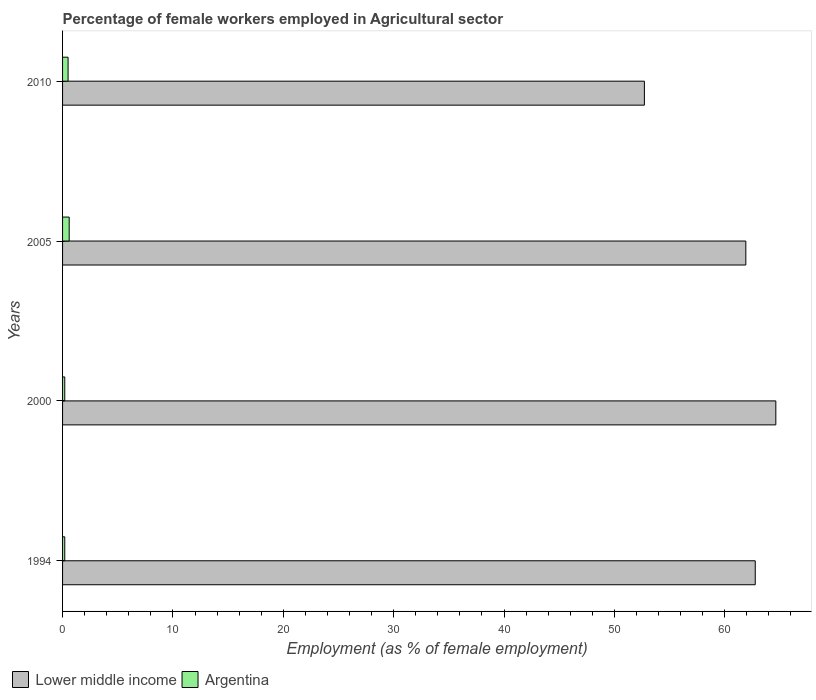How many different coloured bars are there?
Offer a terse response. 2. How many groups of bars are there?
Ensure brevity in your answer.  4. Are the number of bars on each tick of the Y-axis equal?
Make the answer very short. Yes. In how many cases, is the number of bars for a given year not equal to the number of legend labels?
Your response must be concise. 0. What is the percentage of females employed in Agricultural sector in Lower middle income in 2010?
Your answer should be very brief. 52.72. Across all years, what is the maximum percentage of females employed in Agricultural sector in Argentina?
Make the answer very short. 0.6. Across all years, what is the minimum percentage of females employed in Agricultural sector in Argentina?
Provide a succinct answer. 0.2. In which year was the percentage of females employed in Agricultural sector in Argentina maximum?
Keep it short and to the point. 2005. In which year was the percentage of females employed in Agricultural sector in Argentina minimum?
Your response must be concise. 1994. What is the total percentage of females employed in Agricultural sector in Argentina in the graph?
Offer a terse response. 1.5. What is the difference between the percentage of females employed in Agricultural sector in Lower middle income in 1994 and that in 2000?
Make the answer very short. -1.86. What is the difference between the percentage of females employed in Agricultural sector in Argentina in 2005 and the percentage of females employed in Agricultural sector in Lower middle income in 1994?
Offer a very short reply. -62.16. What is the average percentage of females employed in Agricultural sector in Lower middle income per year?
Your response must be concise. 60.5. In the year 2010, what is the difference between the percentage of females employed in Agricultural sector in Argentina and percentage of females employed in Agricultural sector in Lower middle income?
Keep it short and to the point. -52.22. In how many years, is the percentage of females employed in Agricultural sector in Argentina greater than 40 %?
Keep it short and to the point. 0. What is the ratio of the percentage of females employed in Agricultural sector in Lower middle income in 1994 to that in 2010?
Offer a very short reply. 1.19. What is the difference between the highest and the second highest percentage of females employed in Agricultural sector in Lower middle income?
Offer a terse response. 1.86. What is the difference between the highest and the lowest percentage of females employed in Agricultural sector in Lower middle income?
Make the answer very short. 11.91. In how many years, is the percentage of females employed in Agricultural sector in Lower middle income greater than the average percentage of females employed in Agricultural sector in Lower middle income taken over all years?
Your response must be concise. 3. What does the 1st bar from the top in 2005 represents?
Your response must be concise. Argentina. What does the 2nd bar from the bottom in 2010 represents?
Offer a terse response. Argentina. How many bars are there?
Make the answer very short. 8. Does the graph contain any zero values?
Make the answer very short. No. What is the title of the graph?
Offer a terse response. Percentage of female workers employed in Agricultural sector. What is the label or title of the X-axis?
Offer a very short reply. Employment (as % of female employment). What is the Employment (as % of female employment) in Lower middle income in 1994?
Offer a terse response. 62.76. What is the Employment (as % of female employment) in Argentina in 1994?
Provide a succinct answer. 0.2. What is the Employment (as % of female employment) of Lower middle income in 2000?
Keep it short and to the point. 64.63. What is the Employment (as % of female employment) in Argentina in 2000?
Provide a succinct answer. 0.2. What is the Employment (as % of female employment) of Lower middle income in 2005?
Your answer should be very brief. 61.91. What is the Employment (as % of female employment) of Argentina in 2005?
Your answer should be very brief. 0.6. What is the Employment (as % of female employment) in Lower middle income in 2010?
Provide a short and direct response. 52.72. What is the Employment (as % of female employment) of Argentina in 2010?
Ensure brevity in your answer.  0.5. Across all years, what is the maximum Employment (as % of female employment) in Lower middle income?
Offer a very short reply. 64.63. Across all years, what is the maximum Employment (as % of female employment) of Argentina?
Keep it short and to the point. 0.6. Across all years, what is the minimum Employment (as % of female employment) of Lower middle income?
Provide a succinct answer. 52.72. Across all years, what is the minimum Employment (as % of female employment) in Argentina?
Make the answer very short. 0.2. What is the total Employment (as % of female employment) of Lower middle income in the graph?
Provide a short and direct response. 242.02. What is the difference between the Employment (as % of female employment) of Lower middle income in 1994 and that in 2000?
Provide a succinct answer. -1.86. What is the difference between the Employment (as % of female employment) of Argentina in 1994 and that in 2000?
Your response must be concise. 0. What is the difference between the Employment (as % of female employment) in Lower middle income in 1994 and that in 2005?
Offer a very short reply. 0.85. What is the difference between the Employment (as % of female employment) in Lower middle income in 1994 and that in 2010?
Offer a terse response. 10.04. What is the difference between the Employment (as % of female employment) of Argentina in 1994 and that in 2010?
Give a very brief answer. -0.3. What is the difference between the Employment (as % of female employment) in Lower middle income in 2000 and that in 2005?
Make the answer very short. 2.72. What is the difference between the Employment (as % of female employment) in Lower middle income in 2000 and that in 2010?
Ensure brevity in your answer.  11.91. What is the difference between the Employment (as % of female employment) in Lower middle income in 2005 and that in 2010?
Offer a very short reply. 9.19. What is the difference between the Employment (as % of female employment) of Lower middle income in 1994 and the Employment (as % of female employment) of Argentina in 2000?
Your response must be concise. 62.56. What is the difference between the Employment (as % of female employment) of Lower middle income in 1994 and the Employment (as % of female employment) of Argentina in 2005?
Keep it short and to the point. 62.16. What is the difference between the Employment (as % of female employment) of Lower middle income in 1994 and the Employment (as % of female employment) of Argentina in 2010?
Keep it short and to the point. 62.26. What is the difference between the Employment (as % of female employment) in Lower middle income in 2000 and the Employment (as % of female employment) in Argentina in 2005?
Offer a terse response. 64.03. What is the difference between the Employment (as % of female employment) in Lower middle income in 2000 and the Employment (as % of female employment) in Argentina in 2010?
Provide a short and direct response. 64.13. What is the difference between the Employment (as % of female employment) in Lower middle income in 2005 and the Employment (as % of female employment) in Argentina in 2010?
Ensure brevity in your answer.  61.41. What is the average Employment (as % of female employment) in Lower middle income per year?
Make the answer very short. 60.5. What is the average Employment (as % of female employment) of Argentina per year?
Provide a short and direct response. 0.38. In the year 1994, what is the difference between the Employment (as % of female employment) of Lower middle income and Employment (as % of female employment) of Argentina?
Keep it short and to the point. 62.56. In the year 2000, what is the difference between the Employment (as % of female employment) in Lower middle income and Employment (as % of female employment) in Argentina?
Keep it short and to the point. 64.43. In the year 2005, what is the difference between the Employment (as % of female employment) of Lower middle income and Employment (as % of female employment) of Argentina?
Provide a short and direct response. 61.31. In the year 2010, what is the difference between the Employment (as % of female employment) in Lower middle income and Employment (as % of female employment) in Argentina?
Your answer should be compact. 52.22. What is the ratio of the Employment (as % of female employment) of Lower middle income in 1994 to that in 2000?
Offer a terse response. 0.97. What is the ratio of the Employment (as % of female employment) in Argentina in 1994 to that in 2000?
Offer a very short reply. 1. What is the ratio of the Employment (as % of female employment) of Lower middle income in 1994 to that in 2005?
Offer a very short reply. 1.01. What is the ratio of the Employment (as % of female employment) in Argentina in 1994 to that in 2005?
Your answer should be compact. 0.33. What is the ratio of the Employment (as % of female employment) in Lower middle income in 1994 to that in 2010?
Provide a succinct answer. 1.19. What is the ratio of the Employment (as % of female employment) of Argentina in 1994 to that in 2010?
Your answer should be very brief. 0.4. What is the ratio of the Employment (as % of female employment) of Lower middle income in 2000 to that in 2005?
Ensure brevity in your answer.  1.04. What is the ratio of the Employment (as % of female employment) in Argentina in 2000 to that in 2005?
Provide a succinct answer. 0.33. What is the ratio of the Employment (as % of female employment) of Lower middle income in 2000 to that in 2010?
Your answer should be very brief. 1.23. What is the ratio of the Employment (as % of female employment) in Argentina in 2000 to that in 2010?
Give a very brief answer. 0.4. What is the ratio of the Employment (as % of female employment) of Lower middle income in 2005 to that in 2010?
Make the answer very short. 1.17. What is the ratio of the Employment (as % of female employment) in Argentina in 2005 to that in 2010?
Your response must be concise. 1.2. What is the difference between the highest and the second highest Employment (as % of female employment) of Lower middle income?
Give a very brief answer. 1.86. What is the difference between the highest and the lowest Employment (as % of female employment) of Lower middle income?
Provide a succinct answer. 11.91. What is the difference between the highest and the lowest Employment (as % of female employment) in Argentina?
Provide a short and direct response. 0.4. 